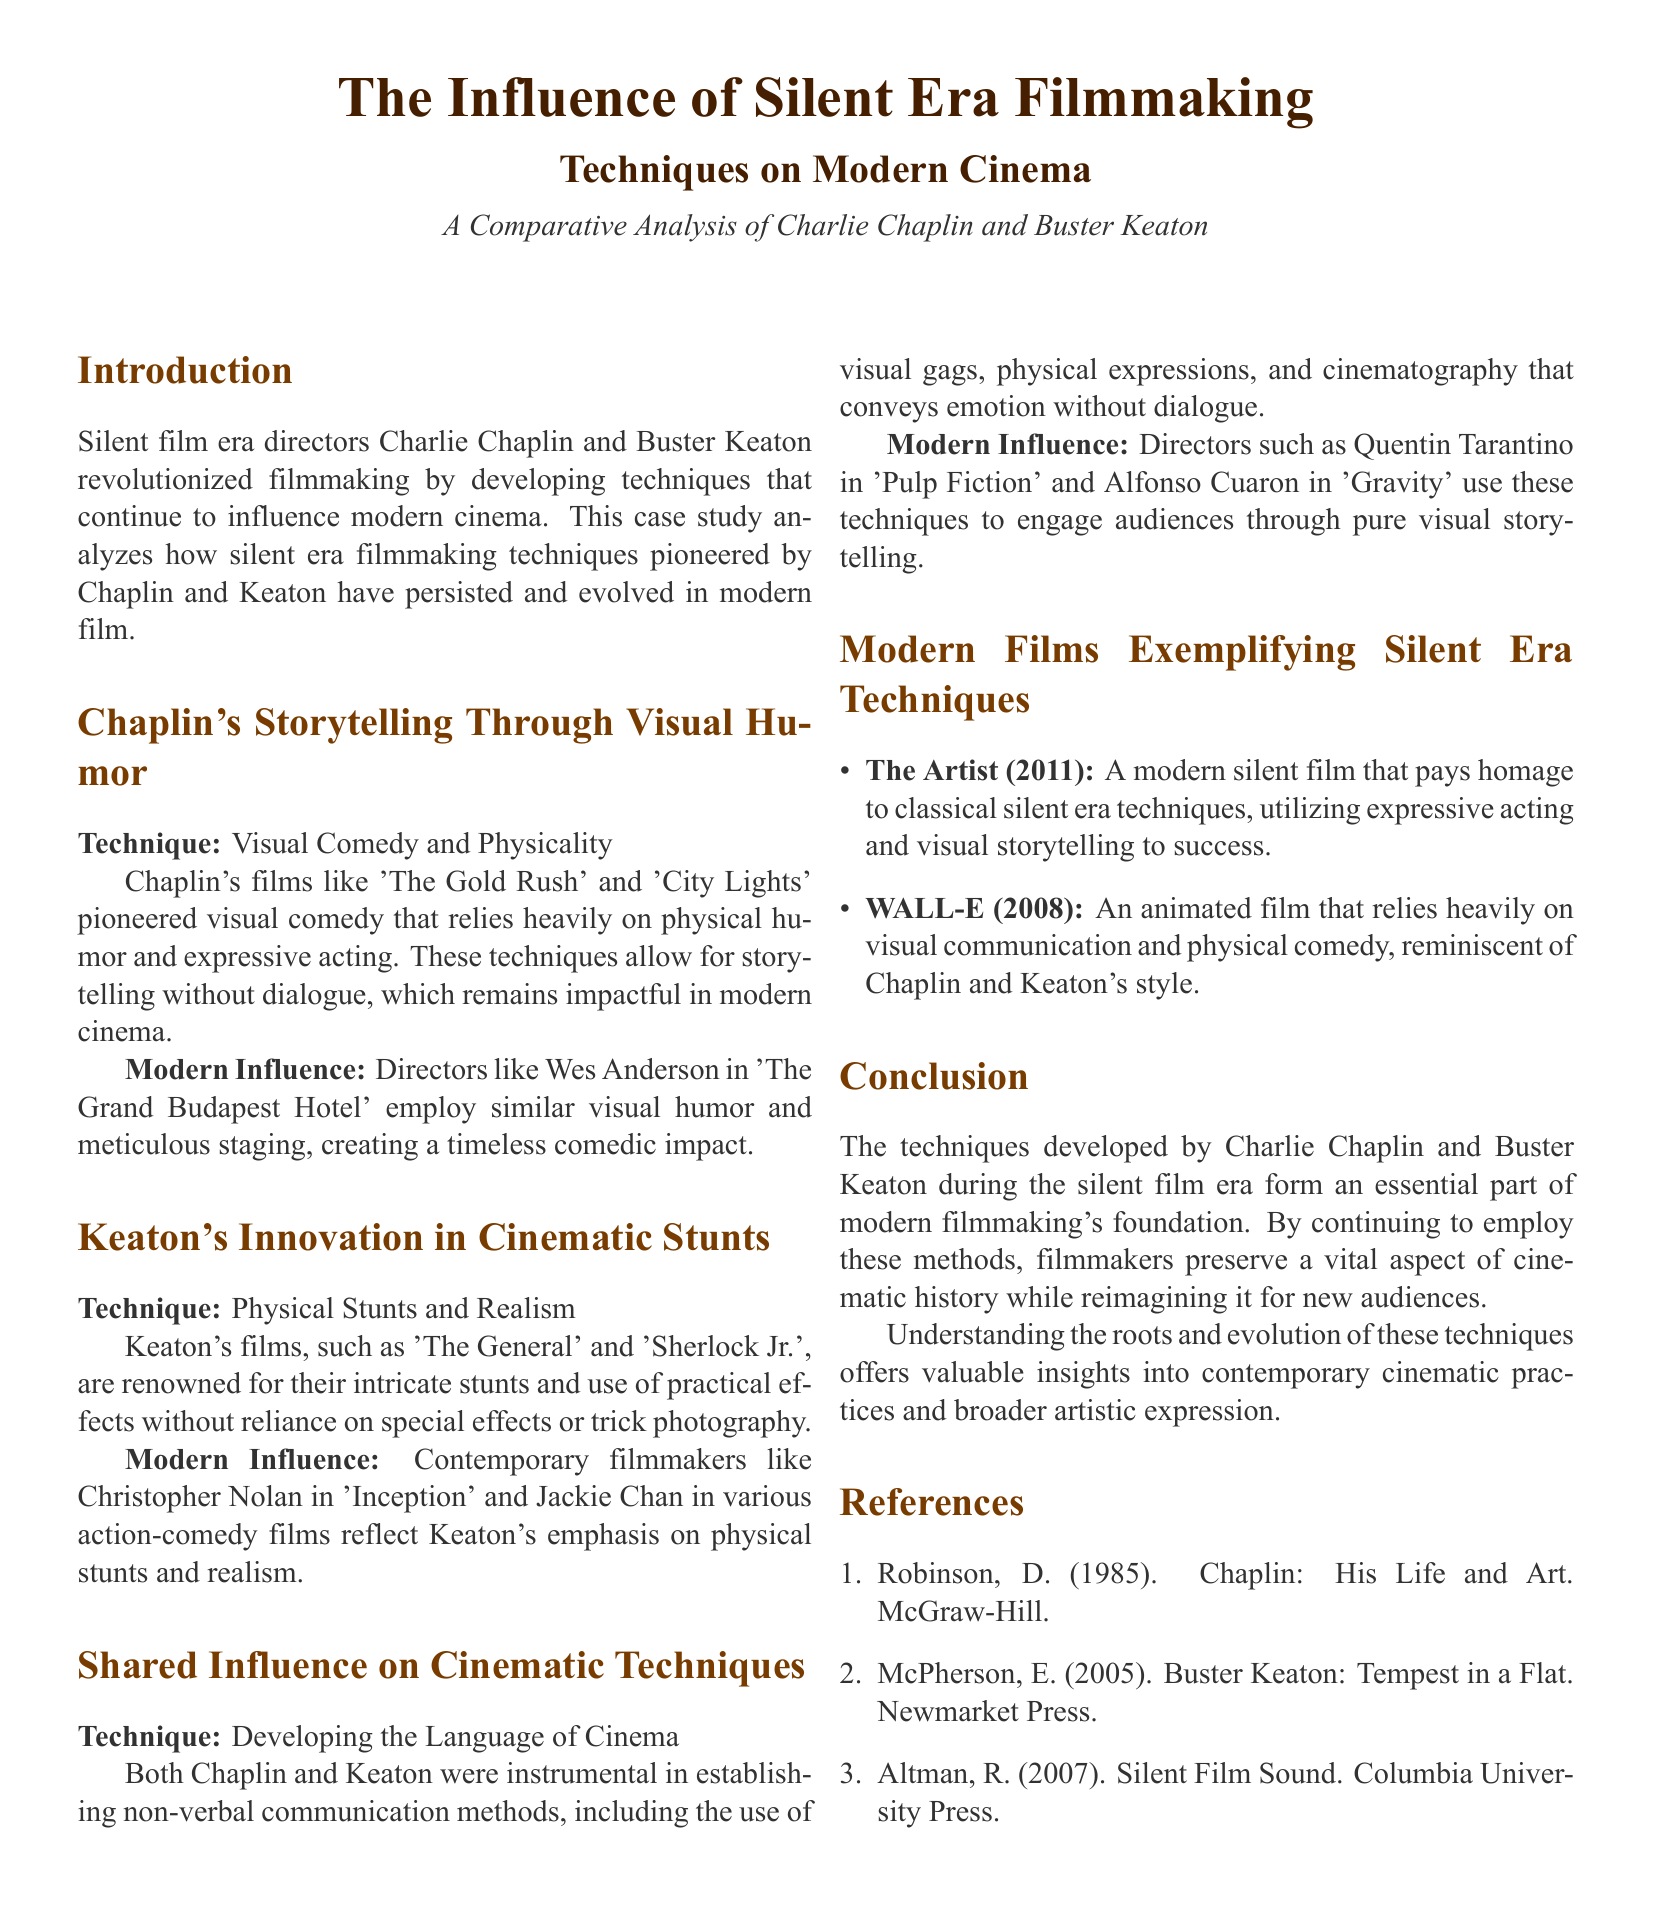What two filmmakers are compared in this case study? The document focuses on Charlie Chaplin and Buster Keaton, emphasizing their contributions to filmmaking techniques.
Answer: Charlie Chaplin and Buster Keaton What technique is associated with Chaplin's films? The case study highlights visual comedy and physicality as key techniques in Chaplin's storytelling.
Answer: Visual Comedy and Physicality Which modern director is mentioned as influenced by Chaplin? Wes Anderson is identified as a contemporary filmmaker who employs similar visual humor and staging.
Answer: Wes Anderson What type of stunts is Buster Keaton known for? The document states that Keaton is renowned for physical stunts and realism in his films.
Answer: Physical Stunts and Realism Name one modern film that exemplifies silent era techniques. The case study lists "The Artist" as a modern film that pays homage to silent era filmmaking methods.
Answer: The Artist Which directors use silent era techniques according to the document? The text mentions Quentin Tarantino and Alfonso Cuaron as filmmakers using non-verbal communication and visual storytelling methods.
Answer: Quentin Tarantino and Alfonso Cuaron What year was "The Artist" released? The document states that "The Artist" was released in 2011, providing a reference for its time period.
Answer: 2011 What remains impactful in modern cinema according to Chaplin's techniques? The study suggests that storytelling without dialogue has a lasting impact on modern filmmaking.
Answer: Storytelling without dialogue 